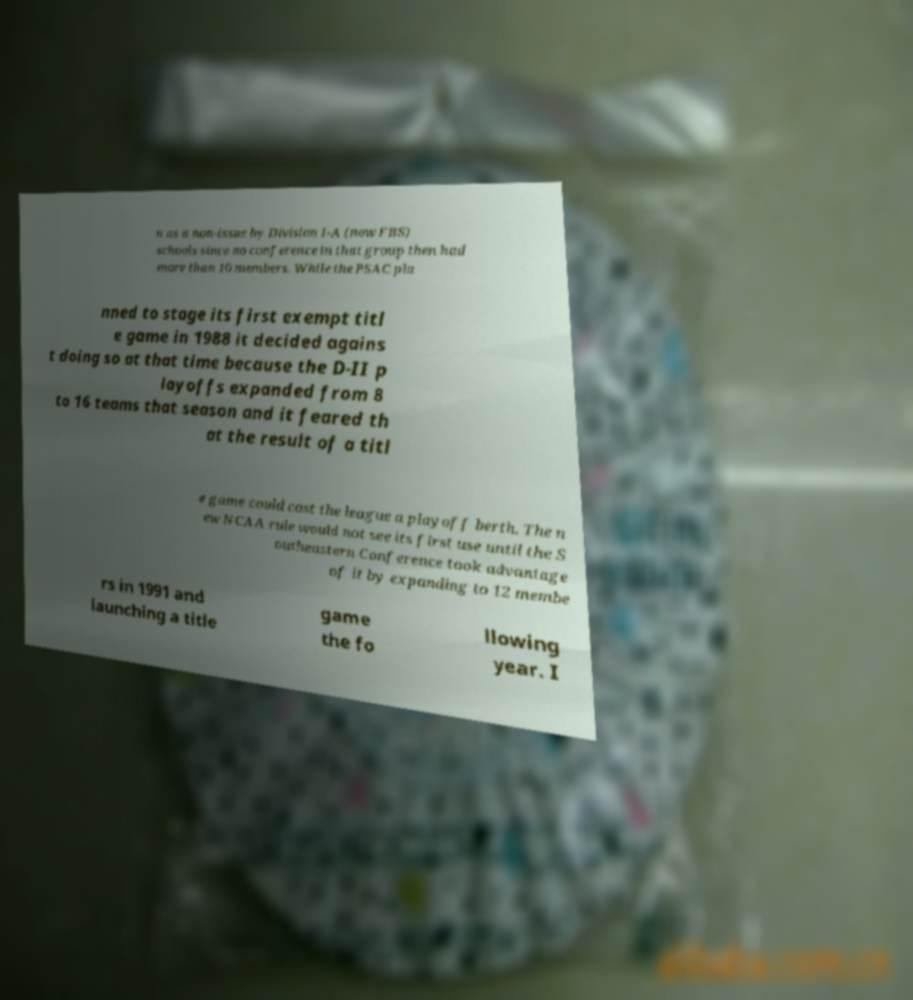Could you assist in decoding the text presented in this image and type it out clearly? n as a non-issue by Division I-A (now FBS) schools since no conference in that group then had more than 10 members. While the PSAC pla nned to stage its first exempt titl e game in 1988 it decided agains t doing so at that time because the D-II p layoffs expanded from 8 to 16 teams that season and it feared th at the result of a titl e game could cost the league a playoff berth. The n ew NCAA rule would not see its first use until the S outheastern Conference took advantage of it by expanding to 12 membe rs in 1991 and launching a title game the fo llowing year. I 